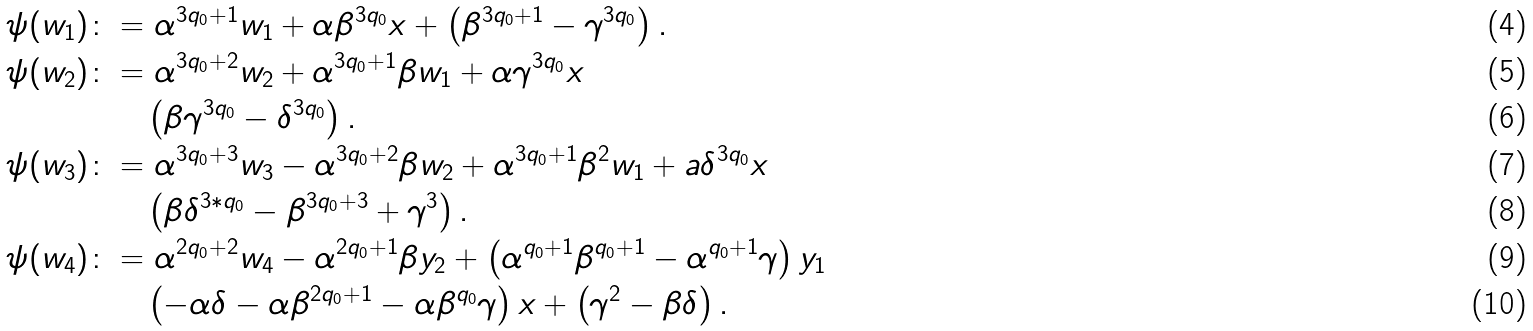<formula> <loc_0><loc_0><loc_500><loc_500>\psi ( w _ { 1 } ) \colon & = \alpha ^ { 3 q _ { 0 } + 1 } w _ { 1 } + \alpha \beta ^ { 3 q _ { 0 } } x + \left ( \beta ^ { 3 q _ { 0 } + 1 } - \gamma ^ { 3 q _ { 0 } } \right ) . \\ \psi ( w _ { 2 } ) \colon & = \alpha ^ { 3 q _ { 0 } + 2 } w _ { 2 } + \alpha ^ { 3 q _ { 0 } + 1 } \beta w _ { 1 } + \alpha \gamma ^ { 3 q _ { 0 } } x \\ & \quad \left ( \beta \gamma ^ { 3 q _ { 0 } } - \delta ^ { 3 q _ { 0 } } \right ) . \\ \psi ( w _ { 3 } ) \colon & = \alpha ^ { 3 q _ { 0 } + 3 } w _ { 3 } - \alpha ^ { 3 q _ { 0 } + 2 } \beta w _ { 2 } + \alpha ^ { 3 q _ { 0 } + 1 } \beta ^ { 2 } w _ { 1 } + a \delta ^ { 3 q _ { 0 } } x \\ & \quad \left ( \beta \delta ^ { 3 * q _ { 0 } } - \beta ^ { 3 q _ { 0 } + 3 } + \gamma ^ { 3 } \right ) . \\ \psi ( w _ { 4 } ) \colon & = \alpha ^ { 2 q _ { 0 } + 2 } w _ { 4 } - \alpha ^ { 2 q _ { 0 } + 1 } \beta y _ { 2 } + \left ( \alpha ^ { q _ { 0 } + 1 } \beta ^ { q _ { 0 } + 1 } - \alpha ^ { q _ { 0 } + 1 } \gamma \right ) y _ { 1 } \\ & \quad \left ( - \alpha \delta - \alpha \beta ^ { 2 q _ { 0 } + 1 } - \alpha \beta ^ { q _ { 0 } } \gamma \right ) x + \left ( \gamma ^ { 2 } - \beta \delta \right ) .</formula> 